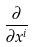<formula> <loc_0><loc_0><loc_500><loc_500>\frac { \partial } { \partial x ^ { i } }</formula> 